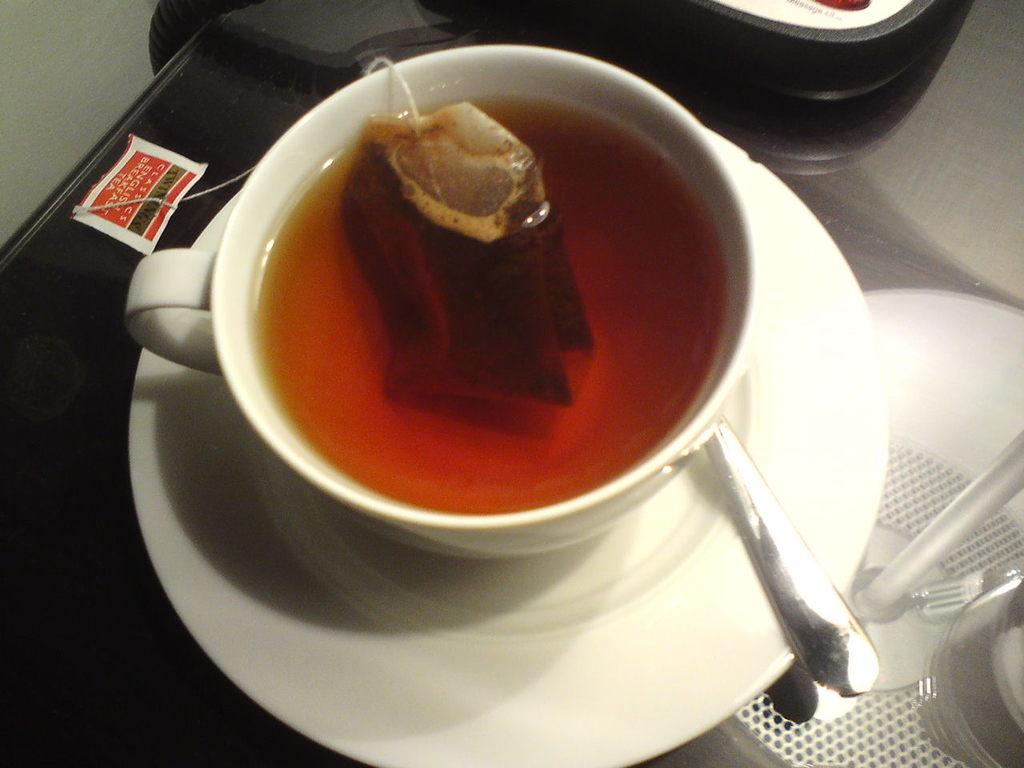What is in the cup that is visible in the image? There is tea in a cup in the image. What is inside the tea to steep it? There is a tea bag in the cup. What is the cup resting on? There is a saucer under the cup. What utensil is present in the image? There is a spoon in the image. What other item can be seen in the image? There is a paper in the image. What type of vein is visible on the paper in the image? There is no vein visible on the paper in the image. Can you tell me how the calculator is being used in the image? There is no calculator present in the image. 